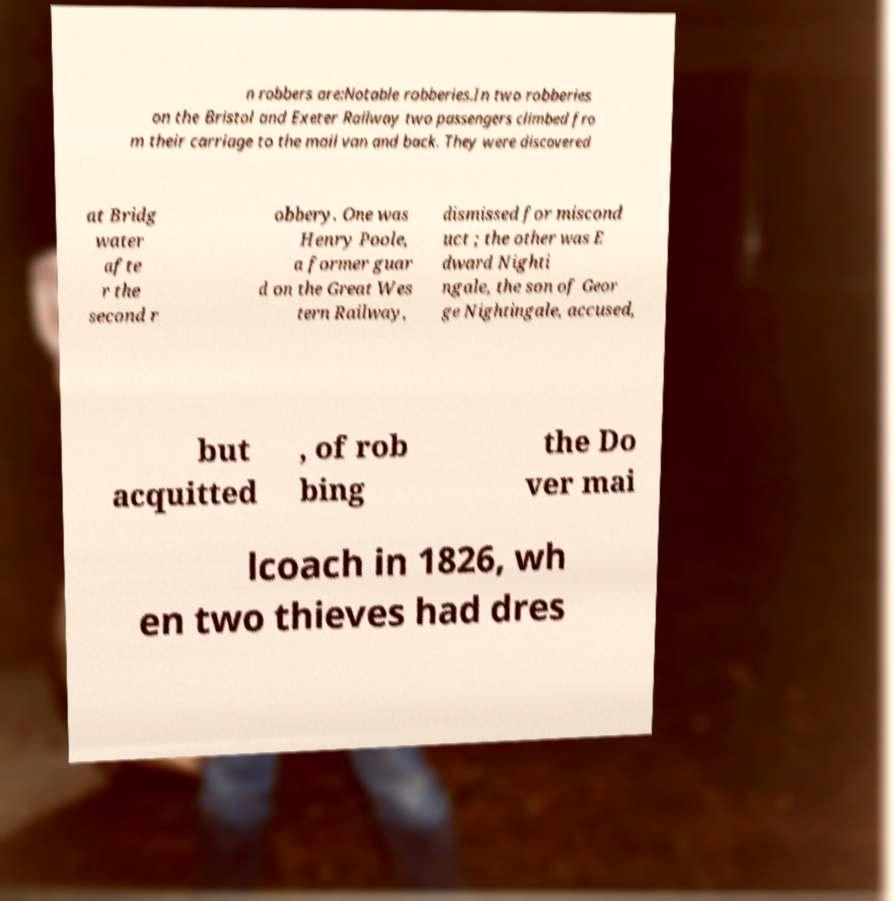Could you extract and type out the text from this image? n robbers are:Notable robberies.In two robberies on the Bristol and Exeter Railway two passengers climbed fro m their carriage to the mail van and back. They were discovered at Bridg water afte r the second r obbery. One was Henry Poole, a former guar d on the Great Wes tern Railway, dismissed for miscond uct ; the other was E dward Nighti ngale, the son of Geor ge Nightingale, accused, but acquitted , of rob bing the Do ver mai lcoach in 1826, wh en two thieves had dres 